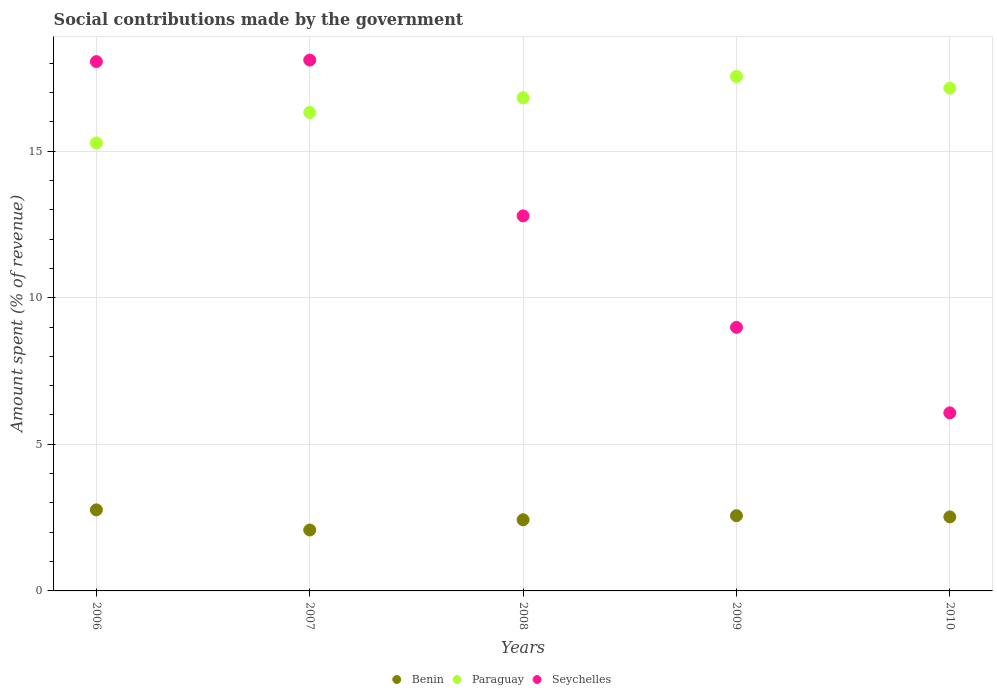How many different coloured dotlines are there?
Keep it short and to the point. 3. Is the number of dotlines equal to the number of legend labels?
Provide a succinct answer. Yes. What is the amount spent (in %) on social contributions in Seychelles in 2008?
Ensure brevity in your answer.  12.79. Across all years, what is the maximum amount spent (in %) on social contributions in Benin?
Your response must be concise. 2.76. Across all years, what is the minimum amount spent (in %) on social contributions in Paraguay?
Offer a very short reply. 15.28. In which year was the amount spent (in %) on social contributions in Paraguay minimum?
Keep it short and to the point. 2006. What is the total amount spent (in %) on social contributions in Seychelles in the graph?
Give a very brief answer. 64.01. What is the difference between the amount spent (in %) on social contributions in Seychelles in 2006 and that in 2008?
Give a very brief answer. 5.26. What is the difference between the amount spent (in %) on social contributions in Paraguay in 2006 and the amount spent (in %) on social contributions in Seychelles in 2010?
Your answer should be compact. 9.21. What is the average amount spent (in %) on social contributions in Seychelles per year?
Make the answer very short. 12.8. In the year 2008, what is the difference between the amount spent (in %) on social contributions in Benin and amount spent (in %) on social contributions in Seychelles?
Ensure brevity in your answer.  -10.36. What is the ratio of the amount spent (in %) on social contributions in Paraguay in 2006 to that in 2007?
Give a very brief answer. 0.94. Is the amount spent (in %) on social contributions in Paraguay in 2008 less than that in 2009?
Keep it short and to the point. Yes. What is the difference between the highest and the second highest amount spent (in %) on social contributions in Benin?
Make the answer very short. 0.2. What is the difference between the highest and the lowest amount spent (in %) on social contributions in Benin?
Your answer should be compact. 0.69. Is it the case that in every year, the sum of the amount spent (in %) on social contributions in Benin and amount spent (in %) on social contributions in Seychelles  is greater than the amount spent (in %) on social contributions in Paraguay?
Your answer should be very brief. No. Does the amount spent (in %) on social contributions in Paraguay monotonically increase over the years?
Provide a succinct answer. No. Is the amount spent (in %) on social contributions in Seychelles strictly greater than the amount spent (in %) on social contributions in Benin over the years?
Offer a terse response. Yes. How many dotlines are there?
Provide a short and direct response. 3. What is the difference between two consecutive major ticks on the Y-axis?
Give a very brief answer. 5. Does the graph contain any zero values?
Make the answer very short. No. Where does the legend appear in the graph?
Offer a terse response. Bottom center. What is the title of the graph?
Keep it short and to the point. Social contributions made by the government. Does "Morocco" appear as one of the legend labels in the graph?
Offer a terse response. No. What is the label or title of the X-axis?
Your response must be concise. Years. What is the label or title of the Y-axis?
Provide a short and direct response. Amount spent (% of revenue). What is the Amount spent (% of revenue) in Benin in 2006?
Your response must be concise. 2.76. What is the Amount spent (% of revenue) in Paraguay in 2006?
Your response must be concise. 15.28. What is the Amount spent (% of revenue) in Seychelles in 2006?
Keep it short and to the point. 18.05. What is the Amount spent (% of revenue) in Benin in 2007?
Keep it short and to the point. 2.08. What is the Amount spent (% of revenue) in Paraguay in 2007?
Ensure brevity in your answer.  16.32. What is the Amount spent (% of revenue) of Seychelles in 2007?
Your answer should be very brief. 18.1. What is the Amount spent (% of revenue) of Benin in 2008?
Offer a very short reply. 2.43. What is the Amount spent (% of revenue) in Paraguay in 2008?
Give a very brief answer. 16.82. What is the Amount spent (% of revenue) in Seychelles in 2008?
Your answer should be very brief. 12.79. What is the Amount spent (% of revenue) of Benin in 2009?
Ensure brevity in your answer.  2.57. What is the Amount spent (% of revenue) in Paraguay in 2009?
Your answer should be compact. 17.54. What is the Amount spent (% of revenue) in Seychelles in 2009?
Offer a very short reply. 8.99. What is the Amount spent (% of revenue) of Benin in 2010?
Your response must be concise. 2.52. What is the Amount spent (% of revenue) of Paraguay in 2010?
Ensure brevity in your answer.  17.15. What is the Amount spent (% of revenue) in Seychelles in 2010?
Ensure brevity in your answer.  6.07. Across all years, what is the maximum Amount spent (% of revenue) of Benin?
Give a very brief answer. 2.76. Across all years, what is the maximum Amount spent (% of revenue) of Paraguay?
Ensure brevity in your answer.  17.54. Across all years, what is the maximum Amount spent (% of revenue) in Seychelles?
Provide a succinct answer. 18.1. Across all years, what is the minimum Amount spent (% of revenue) in Benin?
Your response must be concise. 2.08. Across all years, what is the minimum Amount spent (% of revenue) in Paraguay?
Offer a terse response. 15.28. Across all years, what is the minimum Amount spent (% of revenue) in Seychelles?
Offer a terse response. 6.07. What is the total Amount spent (% of revenue) in Benin in the graph?
Offer a very short reply. 12.36. What is the total Amount spent (% of revenue) of Paraguay in the graph?
Ensure brevity in your answer.  83.1. What is the total Amount spent (% of revenue) in Seychelles in the graph?
Offer a very short reply. 64.01. What is the difference between the Amount spent (% of revenue) of Benin in 2006 and that in 2007?
Ensure brevity in your answer.  0.69. What is the difference between the Amount spent (% of revenue) of Paraguay in 2006 and that in 2007?
Provide a succinct answer. -1.04. What is the difference between the Amount spent (% of revenue) of Seychelles in 2006 and that in 2007?
Offer a terse response. -0.05. What is the difference between the Amount spent (% of revenue) in Benin in 2006 and that in 2008?
Your response must be concise. 0.34. What is the difference between the Amount spent (% of revenue) of Paraguay in 2006 and that in 2008?
Your response must be concise. -1.54. What is the difference between the Amount spent (% of revenue) of Seychelles in 2006 and that in 2008?
Your response must be concise. 5.26. What is the difference between the Amount spent (% of revenue) in Benin in 2006 and that in 2009?
Make the answer very short. 0.2. What is the difference between the Amount spent (% of revenue) of Paraguay in 2006 and that in 2009?
Provide a short and direct response. -2.27. What is the difference between the Amount spent (% of revenue) of Seychelles in 2006 and that in 2009?
Your answer should be compact. 9.06. What is the difference between the Amount spent (% of revenue) in Benin in 2006 and that in 2010?
Offer a terse response. 0.24. What is the difference between the Amount spent (% of revenue) in Paraguay in 2006 and that in 2010?
Offer a very short reply. -1.87. What is the difference between the Amount spent (% of revenue) in Seychelles in 2006 and that in 2010?
Provide a succinct answer. 11.98. What is the difference between the Amount spent (% of revenue) in Benin in 2007 and that in 2008?
Keep it short and to the point. -0.35. What is the difference between the Amount spent (% of revenue) in Paraguay in 2007 and that in 2008?
Provide a succinct answer. -0.5. What is the difference between the Amount spent (% of revenue) of Seychelles in 2007 and that in 2008?
Your response must be concise. 5.31. What is the difference between the Amount spent (% of revenue) of Benin in 2007 and that in 2009?
Make the answer very short. -0.49. What is the difference between the Amount spent (% of revenue) of Paraguay in 2007 and that in 2009?
Offer a very short reply. -1.23. What is the difference between the Amount spent (% of revenue) of Seychelles in 2007 and that in 2009?
Offer a terse response. 9.12. What is the difference between the Amount spent (% of revenue) in Benin in 2007 and that in 2010?
Offer a very short reply. -0.45. What is the difference between the Amount spent (% of revenue) of Paraguay in 2007 and that in 2010?
Give a very brief answer. -0.83. What is the difference between the Amount spent (% of revenue) of Seychelles in 2007 and that in 2010?
Ensure brevity in your answer.  12.03. What is the difference between the Amount spent (% of revenue) in Benin in 2008 and that in 2009?
Provide a succinct answer. -0.14. What is the difference between the Amount spent (% of revenue) in Paraguay in 2008 and that in 2009?
Ensure brevity in your answer.  -0.73. What is the difference between the Amount spent (% of revenue) in Seychelles in 2008 and that in 2009?
Your answer should be compact. 3.8. What is the difference between the Amount spent (% of revenue) of Benin in 2008 and that in 2010?
Give a very brief answer. -0.1. What is the difference between the Amount spent (% of revenue) in Paraguay in 2008 and that in 2010?
Your answer should be very brief. -0.33. What is the difference between the Amount spent (% of revenue) in Seychelles in 2008 and that in 2010?
Your answer should be compact. 6.72. What is the difference between the Amount spent (% of revenue) in Benin in 2009 and that in 2010?
Keep it short and to the point. 0.04. What is the difference between the Amount spent (% of revenue) of Paraguay in 2009 and that in 2010?
Offer a terse response. 0.4. What is the difference between the Amount spent (% of revenue) of Seychelles in 2009 and that in 2010?
Make the answer very short. 2.92. What is the difference between the Amount spent (% of revenue) of Benin in 2006 and the Amount spent (% of revenue) of Paraguay in 2007?
Keep it short and to the point. -13.55. What is the difference between the Amount spent (% of revenue) of Benin in 2006 and the Amount spent (% of revenue) of Seychelles in 2007?
Your answer should be compact. -15.34. What is the difference between the Amount spent (% of revenue) of Paraguay in 2006 and the Amount spent (% of revenue) of Seychelles in 2007?
Ensure brevity in your answer.  -2.83. What is the difference between the Amount spent (% of revenue) in Benin in 2006 and the Amount spent (% of revenue) in Paraguay in 2008?
Your response must be concise. -14.06. What is the difference between the Amount spent (% of revenue) in Benin in 2006 and the Amount spent (% of revenue) in Seychelles in 2008?
Keep it short and to the point. -10.03. What is the difference between the Amount spent (% of revenue) in Paraguay in 2006 and the Amount spent (% of revenue) in Seychelles in 2008?
Keep it short and to the point. 2.49. What is the difference between the Amount spent (% of revenue) in Benin in 2006 and the Amount spent (% of revenue) in Paraguay in 2009?
Keep it short and to the point. -14.78. What is the difference between the Amount spent (% of revenue) of Benin in 2006 and the Amount spent (% of revenue) of Seychelles in 2009?
Your response must be concise. -6.22. What is the difference between the Amount spent (% of revenue) of Paraguay in 2006 and the Amount spent (% of revenue) of Seychelles in 2009?
Ensure brevity in your answer.  6.29. What is the difference between the Amount spent (% of revenue) of Benin in 2006 and the Amount spent (% of revenue) of Paraguay in 2010?
Provide a succinct answer. -14.38. What is the difference between the Amount spent (% of revenue) in Benin in 2006 and the Amount spent (% of revenue) in Seychelles in 2010?
Your response must be concise. -3.31. What is the difference between the Amount spent (% of revenue) in Paraguay in 2006 and the Amount spent (% of revenue) in Seychelles in 2010?
Keep it short and to the point. 9.21. What is the difference between the Amount spent (% of revenue) in Benin in 2007 and the Amount spent (% of revenue) in Paraguay in 2008?
Give a very brief answer. -14.74. What is the difference between the Amount spent (% of revenue) of Benin in 2007 and the Amount spent (% of revenue) of Seychelles in 2008?
Your answer should be very brief. -10.71. What is the difference between the Amount spent (% of revenue) of Paraguay in 2007 and the Amount spent (% of revenue) of Seychelles in 2008?
Offer a very short reply. 3.52. What is the difference between the Amount spent (% of revenue) in Benin in 2007 and the Amount spent (% of revenue) in Paraguay in 2009?
Provide a succinct answer. -15.47. What is the difference between the Amount spent (% of revenue) in Benin in 2007 and the Amount spent (% of revenue) in Seychelles in 2009?
Your answer should be compact. -6.91. What is the difference between the Amount spent (% of revenue) of Paraguay in 2007 and the Amount spent (% of revenue) of Seychelles in 2009?
Provide a succinct answer. 7.33. What is the difference between the Amount spent (% of revenue) in Benin in 2007 and the Amount spent (% of revenue) in Paraguay in 2010?
Keep it short and to the point. -15.07. What is the difference between the Amount spent (% of revenue) in Benin in 2007 and the Amount spent (% of revenue) in Seychelles in 2010?
Ensure brevity in your answer.  -4. What is the difference between the Amount spent (% of revenue) of Paraguay in 2007 and the Amount spent (% of revenue) of Seychelles in 2010?
Give a very brief answer. 10.24. What is the difference between the Amount spent (% of revenue) of Benin in 2008 and the Amount spent (% of revenue) of Paraguay in 2009?
Provide a succinct answer. -15.12. What is the difference between the Amount spent (% of revenue) in Benin in 2008 and the Amount spent (% of revenue) in Seychelles in 2009?
Provide a succinct answer. -6.56. What is the difference between the Amount spent (% of revenue) in Paraguay in 2008 and the Amount spent (% of revenue) in Seychelles in 2009?
Provide a succinct answer. 7.83. What is the difference between the Amount spent (% of revenue) of Benin in 2008 and the Amount spent (% of revenue) of Paraguay in 2010?
Offer a terse response. -14.72. What is the difference between the Amount spent (% of revenue) in Benin in 2008 and the Amount spent (% of revenue) in Seychelles in 2010?
Offer a very short reply. -3.65. What is the difference between the Amount spent (% of revenue) of Paraguay in 2008 and the Amount spent (% of revenue) of Seychelles in 2010?
Provide a succinct answer. 10.75. What is the difference between the Amount spent (% of revenue) of Benin in 2009 and the Amount spent (% of revenue) of Paraguay in 2010?
Provide a succinct answer. -14.58. What is the difference between the Amount spent (% of revenue) of Benin in 2009 and the Amount spent (% of revenue) of Seychelles in 2010?
Provide a short and direct response. -3.51. What is the difference between the Amount spent (% of revenue) in Paraguay in 2009 and the Amount spent (% of revenue) in Seychelles in 2010?
Offer a very short reply. 11.47. What is the average Amount spent (% of revenue) in Benin per year?
Ensure brevity in your answer.  2.47. What is the average Amount spent (% of revenue) in Paraguay per year?
Offer a very short reply. 16.62. What is the average Amount spent (% of revenue) of Seychelles per year?
Provide a succinct answer. 12.8. In the year 2006, what is the difference between the Amount spent (% of revenue) in Benin and Amount spent (% of revenue) in Paraguay?
Provide a short and direct response. -12.51. In the year 2006, what is the difference between the Amount spent (% of revenue) of Benin and Amount spent (% of revenue) of Seychelles?
Make the answer very short. -15.29. In the year 2006, what is the difference between the Amount spent (% of revenue) in Paraguay and Amount spent (% of revenue) in Seychelles?
Your answer should be very brief. -2.77. In the year 2007, what is the difference between the Amount spent (% of revenue) in Benin and Amount spent (% of revenue) in Paraguay?
Offer a terse response. -14.24. In the year 2007, what is the difference between the Amount spent (% of revenue) of Benin and Amount spent (% of revenue) of Seychelles?
Your answer should be very brief. -16.03. In the year 2007, what is the difference between the Amount spent (% of revenue) of Paraguay and Amount spent (% of revenue) of Seychelles?
Provide a succinct answer. -1.79. In the year 2008, what is the difference between the Amount spent (% of revenue) in Benin and Amount spent (% of revenue) in Paraguay?
Keep it short and to the point. -14.39. In the year 2008, what is the difference between the Amount spent (% of revenue) of Benin and Amount spent (% of revenue) of Seychelles?
Offer a terse response. -10.36. In the year 2008, what is the difference between the Amount spent (% of revenue) of Paraguay and Amount spent (% of revenue) of Seychelles?
Provide a succinct answer. 4.03. In the year 2009, what is the difference between the Amount spent (% of revenue) of Benin and Amount spent (% of revenue) of Paraguay?
Your answer should be very brief. -14.98. In the year 2009, what is the difference between the Amount spent (% of revenue) of Benin and Amount spent (% of revenue) of Seychelles?
Offer a very short reply. -6.42. In the year 2009, what is the difference between the Amount spent (% of revenue) of Paraguay and Amount spent (% of revenue) of Seychelles?
Provide a succinct answer. 8.56. In the year 2010, what is the difference between the Amount spent (% of revenue) in Benin and Amount spent (% of revenue) in Paraguay?
Give a very brief answer. -14.62. In the year 2010, what is the difference between the Amount spent (% of revenue) in Benin and Amount spent (% of revenue) in Seychelles?
Give a very brief answer. -3.55. In the year 2010, what is the difference between the Amount spent (% of revenue) of Paraguay and Amount spent (% of revenue) of Seychelles?
Your answer should be compact. 11.07. What is the ratio of the Amount spent (% of revenue) of Benin in 2006 to that in 2007?
Your response must be concise. 1.33. What is the ratio of the Amount spent (% of revenue) of Paraguay in 2006 to that in 2007?
Offer a very short reply. 0.94. What is the ratio of the Amount spent (% of revenue) in Seychelles in 2006 to that in 2007?
Offer a terse response. 1. What is the ratio of the Amount spent (% of revenue) of Benin in 2006 to that in 2008?
Your response must be concise. 1.14. What is the ratio of the Amount spent (% of revenue) of Paraguay in 2006 to that in 2008?
Make the answer very short. 0.91. What is the ratio of the Amount spent (% of revenue) of Seychelles in 2006 to that in 2008?
Make the answer very short. 1.41. What is the ratio of the Amount spent (% of revenue) in Benin in 2006 to that in 2009?
Keep it short and to the point. 1.08. What is the ratio of the Amount spent (% of revenue) in Paraguay in 2006 to that in 2009?
Ensure brevity in your answer.  0.87. What is the ratio of the Amount spent (% of revenue) in Seychelles in 2006 to that in 2009?
Offer a terse response. 2.01. What is the ratio of the Amount spent (% of revenue) of Benin in 2006 to that in 2010?
Your answer should be very brief. 1.1. What is the ratio of the Amount spent (% of revenue) in Paraguay in 2006 to that in 2010?
Your answer should be compact. 0.89. What is the ratio of the Amount spent (% of revenue) in Seychelles in 2006 to that in 2010?
Your answer should be very brief. 2.97. What is the ratio of the Amount spent (% of revenue) in Benin in 2007 to that in 2008?
Provide a short and direct response. 0.86. What is the ratio of the Amount spent (% of revenue) of Paraguay in 2007 to that in 2008?
Offer a terse response. 0.97. What is the ratio of the Amount spent (% of revenue) of Seychelles in 2007 to that in 2008?
Keep it short and to the point. 1.42. What is the ratio of the Amount spent (% of revenue) of Benin in 2007 to that in 2009?
Your response must be concise. 0.81. What is the ratio of the Amount spent (% of revenue) in Paraguay in 2007 to that in 2009?
Your response must be concise. 0.93. What is the ratio of the Amount spent (% of revenue) in Seychelles in 2007 to that in 2009?
Provide a succinct answer. 2.01. What is the ratio of the Amount spent (% of revenue) in Benin in 2007 to that in 2010?
Give a very brief answer. 0.82. What is the ratio of the Amount spent (% of revenue) in Paraguay in 2007 to that in 2010?
Your answer should be compact. 0.95. What is the ratio of the Amount spent (% of revenue) in Seychelles in 2007 to that in 2010?
Your response must be concise. 2.98. What is the ratio of the Amount spent (% of revenue) in Benin in 2008 to that in 2009?
Provide a short and direct response. 0.95. What is the ratio of the Amount spent (% of revenue) in Paraguay in 2008 to that in 2009?
Your response must be concise. 0.96. What is the ratio of the Amount spent (% of revenue) in Seychelles in 2008 to that in 2009?
Give a very brief answer. 1.42. What is the ratio of the Amount spent (% of revenue) of Benin in 2008 to that in 2010?
Make the answer very short. 0.96. What is the ratio of the Amount spent (% of revenue) of Seychelles in 2008 to that in 2010?
Give a very brief answer. 2.11. What is the ratio of the Amount spent (% of revenue) in Benin in 2009 to that in 2010?
Ensure brevity in your answer.  1.02. What is the ratio of the Amount spent (% of revenue) in Paraguay in 2009 to that in 2010?
Your answer should be compact. 1.02. What is the ratio of the Amount spent (% of revenue) of Seychelles in 2009 to that in 2010?
Offer a terse response. 1.48. What is the difference between the highest and the second highest Amount spent (% of revenue) in Benin?
Keep it short and to the point. 0.2. What is the difference between the highest and the second highest Amount spent (% of revenue) in Paraguay?
Provide a succinct answer. 0.4. What is the difference between the highest and the second highest Amount spent (% of revenue) in Seychelles?
Give a very brief answer. 0.05. What is the difference between the highest and the lowest Amount spent (% of revenue) of Benin?
Keep it short and to the point. 0.69. What is the difference between the highest and the lowest Amount spent (% of revenue) of Paraguay?
Your answer should be compact. 2.27. What is the difference between the highest and the lowest Amount spent (% of revenue) of Seychelles?
Your response must be concise. 12.03. 